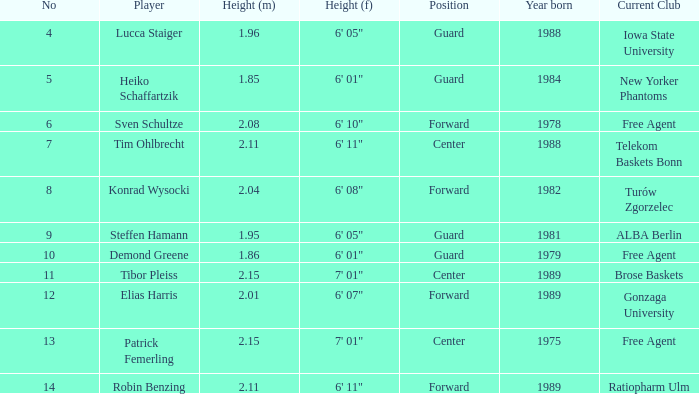Determine the height of the sportsman born in 198 1.95. Can you give me this table as a dict? {'header': ['No', 'Player', 'Height (m)', 'Height (f)', 'Position', 'Year born', 'Current Club'], 'rows': [['4', 'Lucca Staiger', '1.96', '6\' 05"', 'Guard', '1988', 'Iowa State University'], ['5', 'Heiko Schaffartzik', '1.85', '6\' 01"', 'Guard', '1984', 'New Yorker Phantoms'], ['6', 'Sven Schultze', '2.08', '6\' 10"', 'Forward', '1978', 'Free Agent'], ['7', 'Tim Ohlbrecht', '2.11', '6\' 11"', 'Center', '1988', 'Telekom Baskets Bonn'], ['8', 'Konrad Wysocki', '2.04', '6\' 08"', 'Forward', '1982', 'Turów Zgorzelec'], ['9', 'Steffen Hamann', '1.95', '6\' 05"', 'Guard', '1981', 'ALBA Berlin'], ['10', 'Demond Greene', '1.86', '6\' 01"', 'Guard', '1979', 'Free Agent'], ['11', 'Tibor Pleiss', '2.15', '7\' 01"', 'Center', '1989', 'Brose Baskets'], ['12', 'Elias Harris', '2.01', '6\' 07"', 'Forward', '1989', 'Gonzaga University'], ['13', 'Patrick Femerling', '2.15', '7\' 01"', 'Center', '1975', 'Free Agent'], ['14', 'Robin Benzing', '2.11', '6\' 11"', 'Forward', '1989', 'Ratiopharm Ulm']]} 